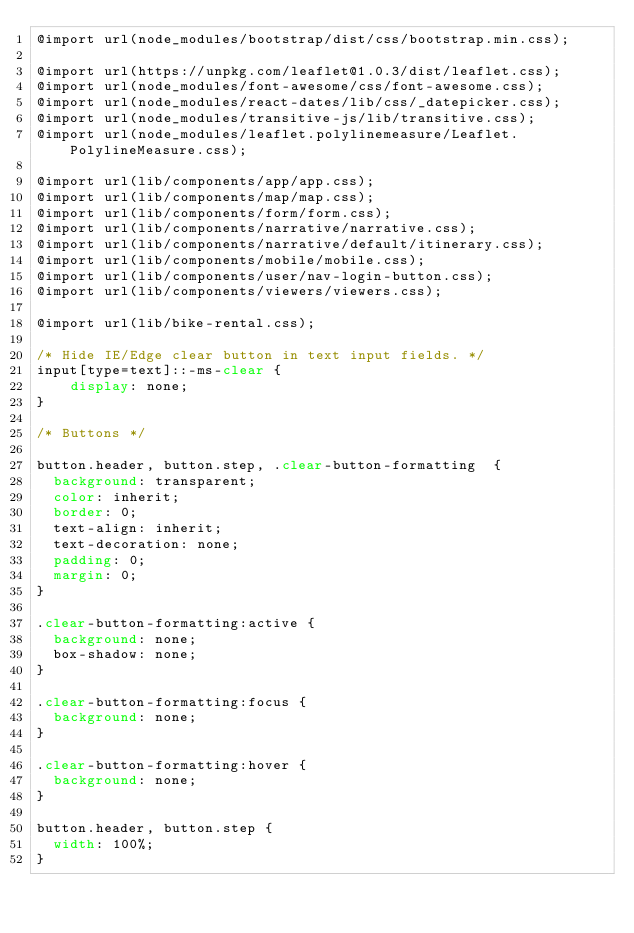Convert code to text. <code><loc_0><loc_0><loc_500><loc_500><_CSS_>@import url(node_modules/bootstrap/dist/css/bootstrap.min.css);

@import url(https://unpkg.com/leaflet@1.0.3/dist/leaflet.css);
@import url(node_modules/font-awesome/css/font-awesome.css);
@import url(node_modules/react-dates/lib/css/_datepicker.css);
@import url(node_modules/transitive-js/lib/transitive.css);
@import url(node_modules/leaflet.polylinemeasure/Leaflet.PolylineMeasure.css);

@import url(lib/components/app/app.css);
@import url(lib/components/map/map.css);
@import url(lib/components/form/form.css);
@import url(lib/components/narrative/narrative.css);
@import url(lib/components/narrative/default/itinerary.css);
@import url(lib/components/mobile/mobile.css);
@import url(lib/components/user/nav-login-button.css);
@import url(lib/components/viewers/viewers.css);

@import url(lib/bike-rental.css);

/* Hide IE/Edge clear button in text input fields. */
input[type=text]::-ms-clear {
    display: none;
}

/* Buttons */

button.header, button.step, .clear-button-formatting  {
  background: transparent;
  color: inherit;
  border: 0;
  text-align: inherit;
  text-decoration: none;
  padding: 0;
  margin: 0;
}

.clear-button-formatting:active {
  background: none;
  box-shadow: none;
}

.clear-button-formatting:focus {
  background: none;
}

.clear-button-formatting:hover {
  background: none;
}

button.header, button.step {
  width: 100%;
}
</code> 